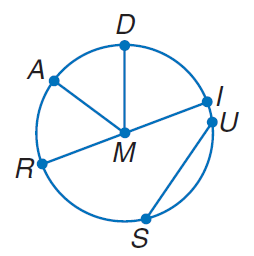Answer the mathemtical geometry problem and directly provide the correct option letter.
Question: If M D = 7, find R I.
Choices: A: 7 B: 14 C: 21 D: 28 B 